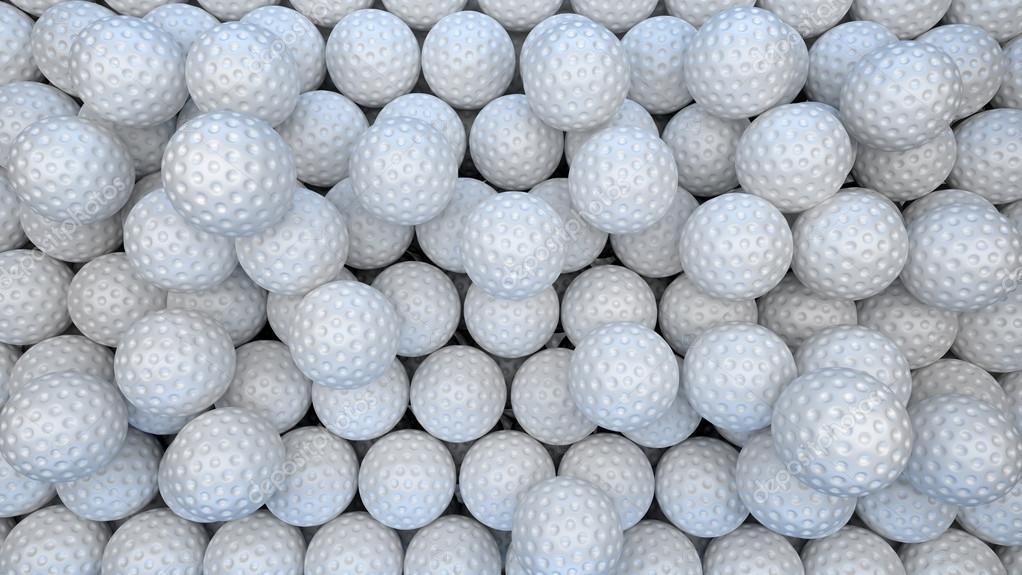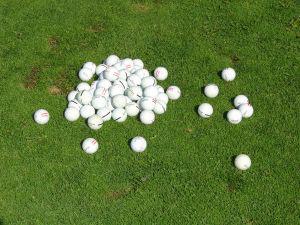The first image is the image on the left, the second image is the image on the right. Analyze the images presented: Is the assertion "An image features a tipped-over mesh-type bucket spilling golf balls." valid? Answer yes or no. No. The first image is the image on the left, the second image is the image on the right. Analyze the images presented: Is the assertion "Balls are pouring out of a mesh green basket." valid? Answer yes or no. No. 